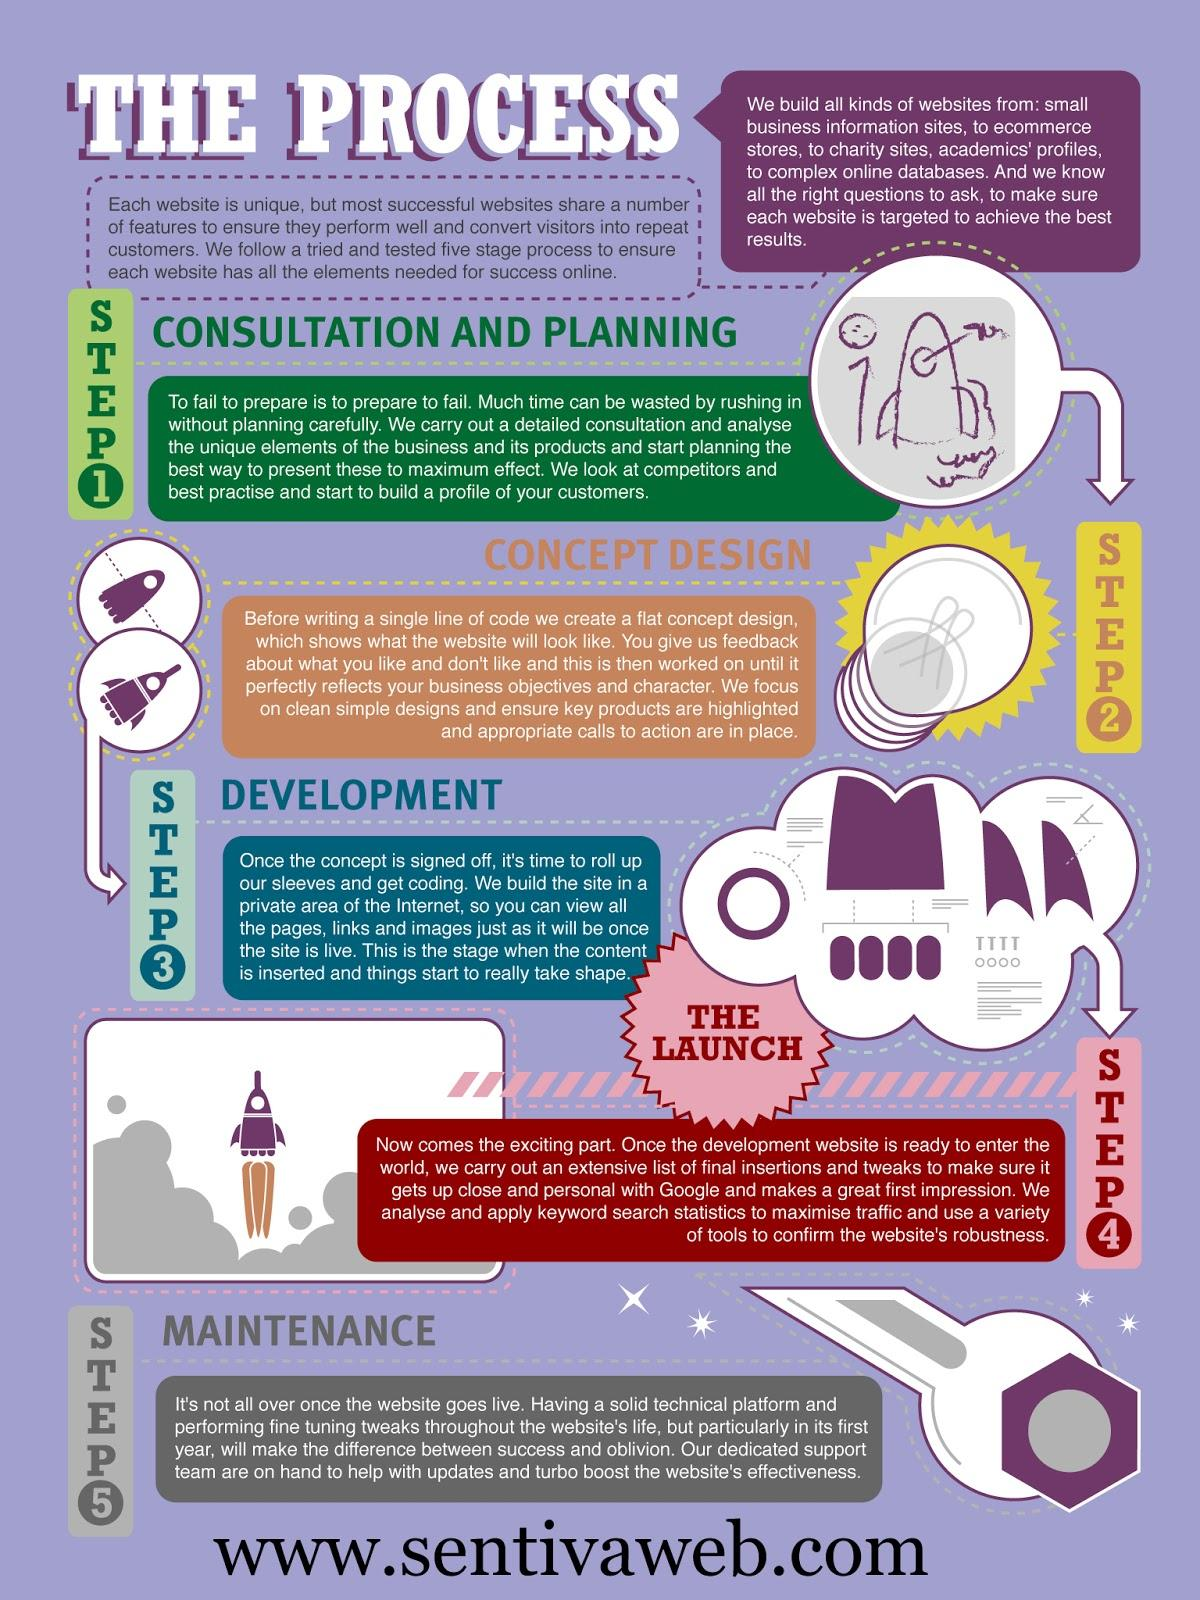Give some essential details in this illustration. Once the development is completed, the launch is the next step. The first step in building a website is consultation and planning. In the step of the development process where coding commences, we begin programming. In the step of website development where content is inserted, the content is added to the website. In step 2, a concept design is created. 